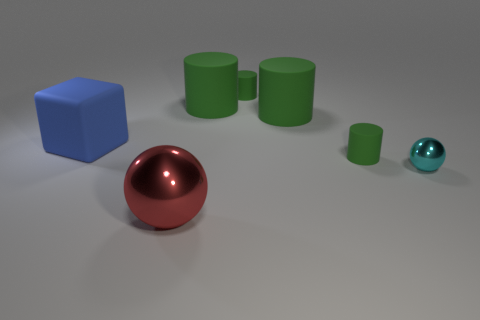Subtract all green cylinders. How many were subtracted if there are1green cylinders left? 3 Subtract all red cylinders. Subtract all green spheres. How many cylinders are left? 4 Add 1 small balls. How many objects exist? 8 Subtract all spheres. How many objects are left? 5 Add 1 blocks. How many blocks are left? 2 Add 6 red shiny objects. How many red shiny objects exist? 7 Subtract 0 green spheres. How many objects are left? 7 Subtract all tiny yellow metallic blocks. Subtract all big blue cubes. How many objects are left? 6 